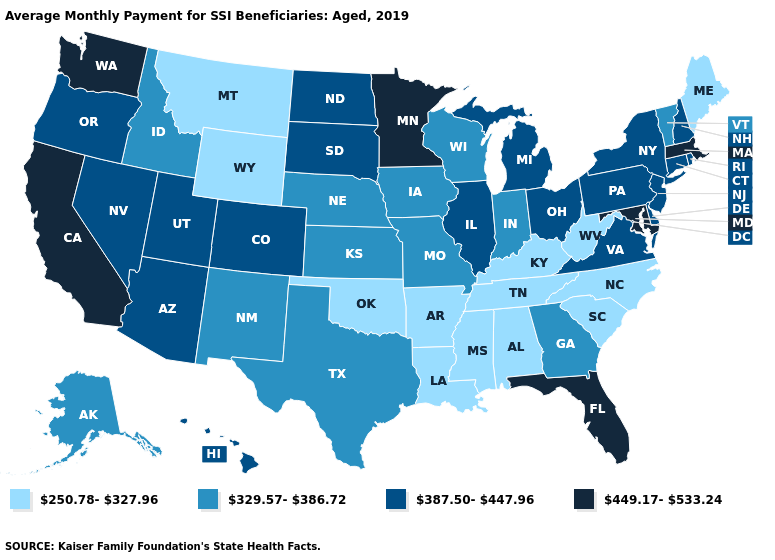What is the value of New Jersey?
Quick response, please. 387.50-447.96. What is the value of New Mexico?
Concise answer only. 329.57-386.72. Name the states that have a value in the range 387.50-447.96?
Answer briefly. Arizona, Colorado, Connecticut, Delaware, Hawaii, Illinois, Michigan, Nevada, New Hampshire, New Jersey, New York, North Dakota, Ohio, Oregon, Pennsylvania, Rhode Island, South Dakota, Utah, Virginia. Among the states that border Texas , does Arkansas have the lowest value?
Write a very short answer. Yes. Does Utah have the lowest value in the USA?
Short answer required. No. What is the lowest value in states that border Kentucky?
Give a very brief answer. 250.78-327.96. What is the highest value in the USA?
Concise answer only. 449.17-533.24. Does Indiana have a lower value than Florida?
Write a very short answer. Yes. Name the states that have a value in the range 250.78-327.96?
Keep it brief. Alabama, Arkansas, Kentucky, Louisiana, Maine, Mississippi, Montana, North Carolina, Oklahoma, South Carolina, Tennessee, West Virginia, Wyoming. Name the states that have a value in the range 449.17-533.24?
Answer briefly. California, Florida, Maryland, Massachusetts, Minnesota, Washington. What is the lowest value in states that border New York?
Be succinct. 329.57-386.72. Does Massachusetts have the highest value in the Northeast?
Be succinct. Yes. Name the states that have a value in the range 250.78-327.96?
Give a very brief answer. Alabama, Arkansas, Kentucky, Louisiana, Maine, Mississippi, Montana, North Carolina, Oklahoma, South Carolina, Tennessee, West Virginia, Wyoming. Does the first symbol in the legend represent the smallest category?
Short answer required. Yes. 